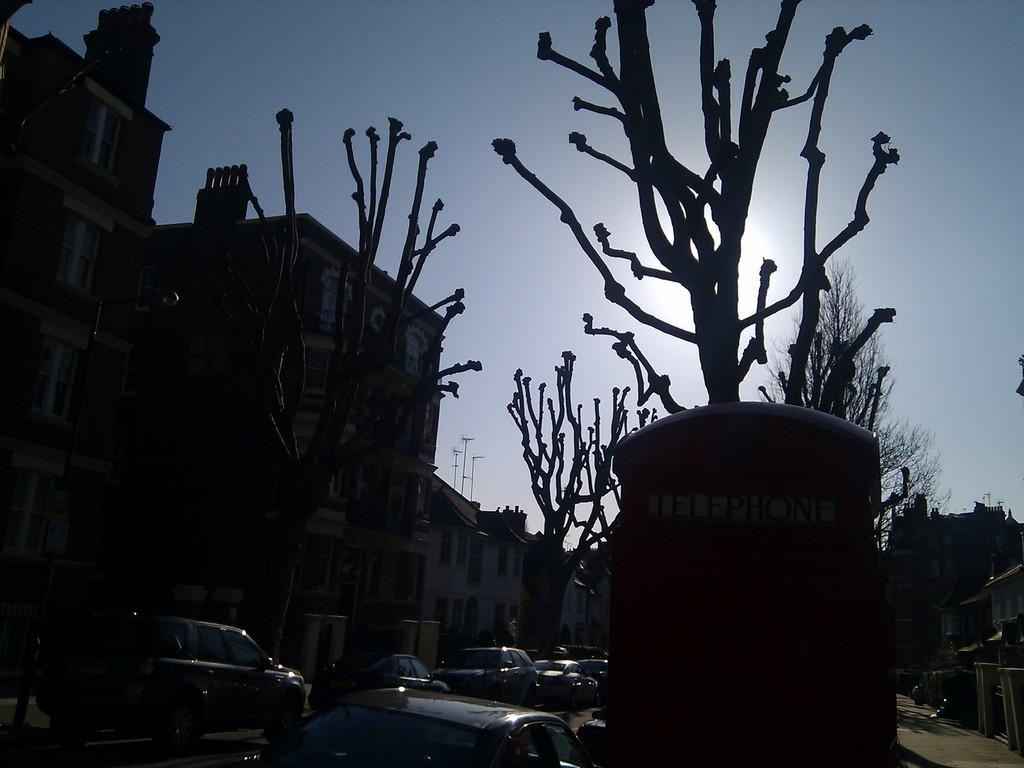What types of living organisms can be seen in the image? Plants and trees are visible in the image. What can be seen on the road at the bottom of the image? Cars are visible on the road at the bottom of the image. What structures are located on the left side of the image? There are buildings on the left side of the image. What is visible at the top of the image? The sky is visible at the top of the image. What type of apparel is being worn by the dinosaurs in the image? There are no dinosaurs present in the image, so there is no apparel to describe. 